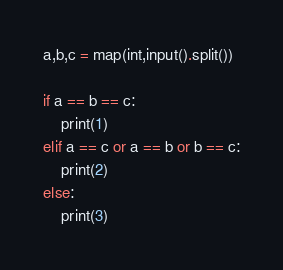Convert code to text. <code><loc_0><loc_0><loc_500><loc_500><_Python_>a,b,c = map(int,input().split())

if a == b == c:
  	print(1)
elif a == c or a == b or b == c:
  	print(2)
else:
  	print(3)</code> 